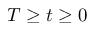Convert formula to latex. <formula><loc_0><loc_0><loc_500><loc_500>T \geq t \geq 0</formula> 